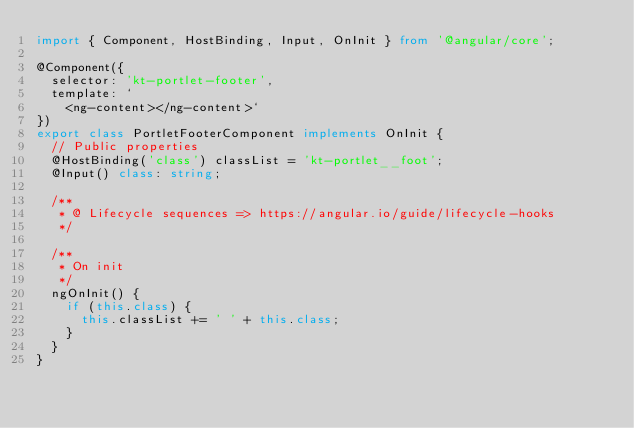<code> <loc_0><loc_0><loc_500><loc_500><_TypeScript_>import { Component, HostBinding, Input, OnInit } from '@angular/core';

@Component({
	selector: 'kt-portlet-footer',
	template: `
		<ng-content></ng-content>`
})
export class PortletFooterComponent implements OnInit {
	// Public properties
	@HostBinding('class') classList = 'kt-portlet__foot';
	@Input() class: string;

	/**
	 * @ Lifecycle sequences => https://angular.io/guide/lifecycle-hooks
	 */

	/**
	 * On init
	 */
	ngOnInit() {
		if (this.class) {
			this.classList += ' ' + this.class;
		}
	}
}
</code> 